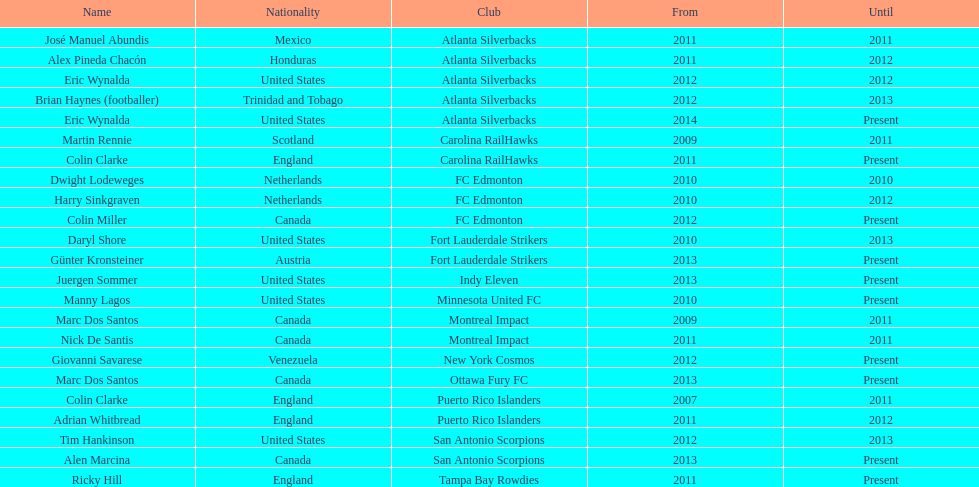In which country did both marc dos santos and colin miller serve as coaches? Canada. 